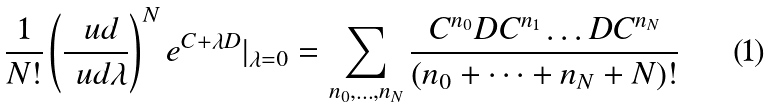<formula> <loc_0><loc_0><loc_500><loc_500>\frac { 1 } { N ! } \left ( \frac { \ u d } { \ u d \lambda } \right ) ^ { N } e ^ { C + \lambda D } | _ { \lambda = 0 } = \sum _ { n _ { 0 } , \dots , n _ { N } } \frac { C ^ { n _ { 0 } } D C ^ { n _ { 1 } } \dots D C ^ { n _ { N } } } { ( n _ { 0 } + \dots + n _ { N } + N ) ! }</formula> 